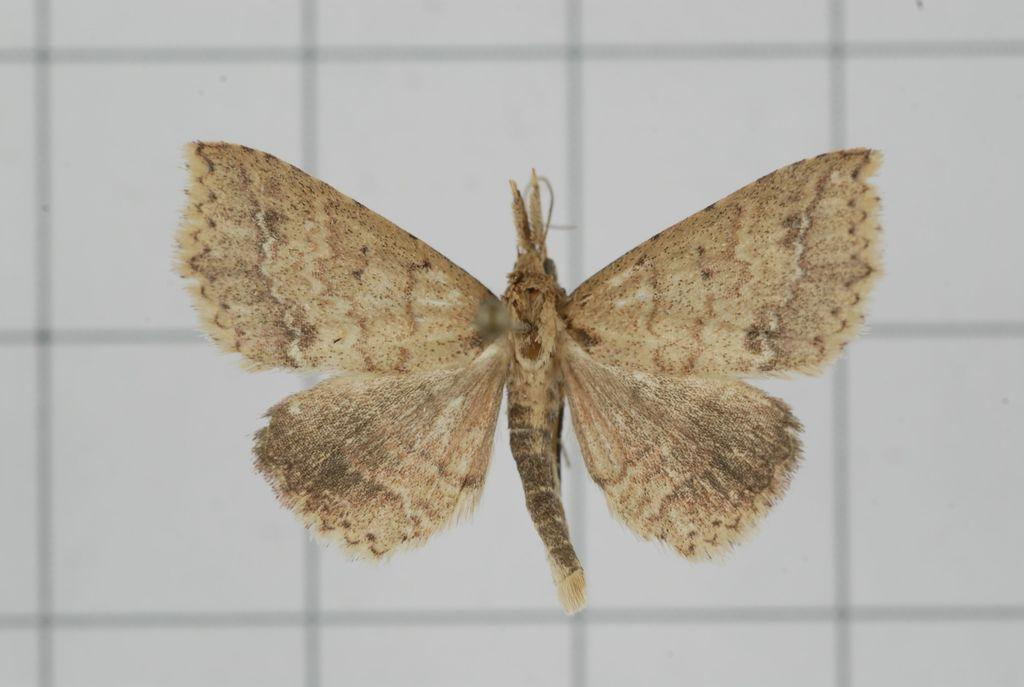What is the main subject of the image? There is a butterfly in the image. What is the color of the background in the image? The background of the image is white. How many arms can be seen on the butterfly in the image? Butterflies do not have arms; they have wings. In the image, the butterfly has wings, not arms. 